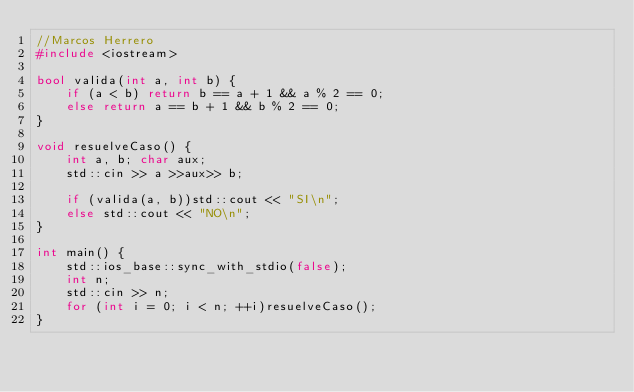Convert code to text. <code><loc_0><loc_0><loc_500><loc_500><_C++_>//Marcos Herrero
#include <iostream>

bool valida(int a, int b) {
	if (a < b) return b == a + 1 && a % 2 == 0;
	else return a == b + 1 && b % 2 == 0;
}

void resuelveCaso() {
	int a, b; char aux;
	std::cin >> a >>aux>> b;
	
	if (valida(a, b))std::cout << "SI\n";
	else std::cout << "NO\n";
}

int main() {
	std::ios_base::sync_with_stdio(false);
	int n;
	std::cin >> n;
	for (int i = 0; i < n; ++i)resuelveCaso();
}</code> 